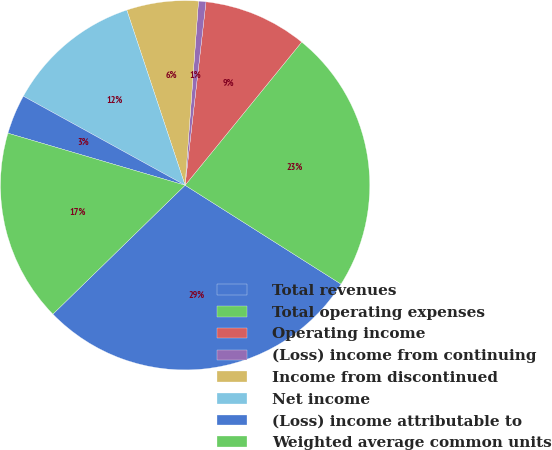Convert chart. <chart><loc_0><loc_0><loc_500><loc_500><pie_chart><fcel>Total revenues<fcel>Total operating expenses<fcel>Operating income<fcel>(Loss) income from continuing<fcel>Income from discontinued<fcel>Net income<fcel>(Loss) income attributable to<fcel>Weighted average common units<nl><fcel>28.71%<fcel>23.12%<fcel>9.07%<fcel>0.65%<fcel>6.27%<fcel>11.88%<fcel>3.46%<fcel>16.85%<nl></chart> 